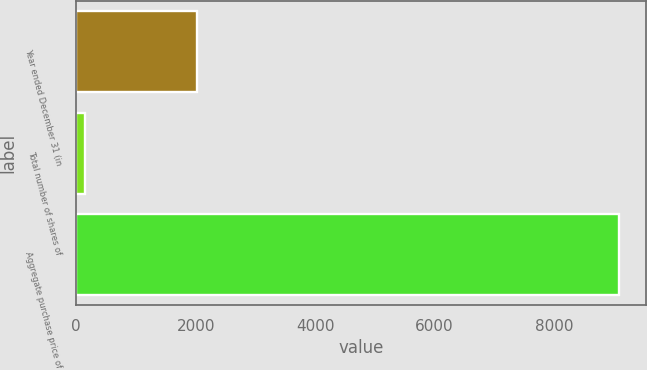Convert chart to OTSL. <chart><loc_0><loc_0><loc_500><loc_500><bar_chart><fcel>Year ended December 31 (in<fcel>Total number of shares of<fcel>Aggregate purchase price of<nl><fcel>2016<fcel>140.4<fcel>9082<nl></chart> 